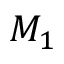Convert formula to latex. <formula><loc_0><loc_0><loc_500><loc_500>M _ { 1 }</formula> 